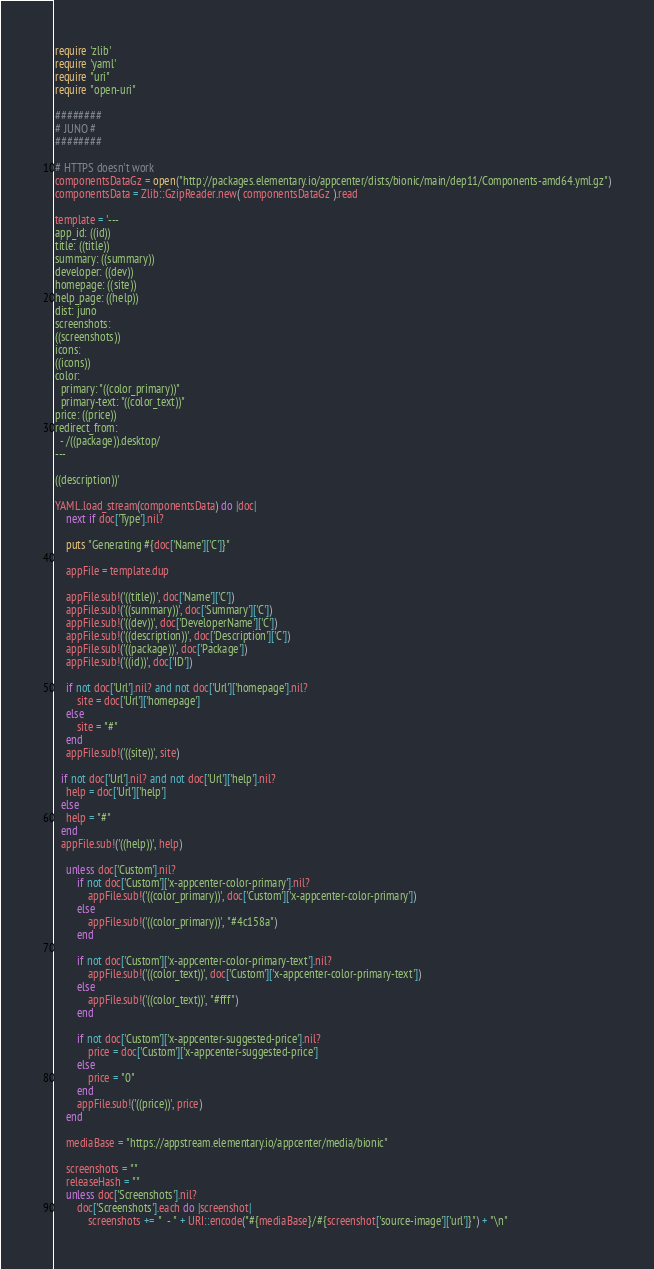<code> <loc_0><loc_0><loc_500><loc_500><_Ruby_>require 'zlib'
require 'yaml'
require "uri"
require "open-uri"

########
# JUNO #
########

# HTTPS doesn't work
componentsDataGz = open("http://packages.elementary.io/appcenter/dists/bionic/main/dep11/Components-amd64.yml.gz")
componentsData = Zlib::GzipReader.new( componentsDataGz ).read

template = '---
app_id: ((id))
title: ((title))
summary: ((summary))
developer: ((dev))
homepage: ((site))
help_page: ((help))
dist: juno
screenshots:
((screenshots))
icons:
((icons))
color:
  primary: "((color_primary))"
  primary-text: "((color_text))"
price: ((price))
redirect_from:
  - /((package)).desktop/
---

((description))'

YAML.load_stream(componentsData) do |doc|
	next if doc['Type'].nil?

	puts "Generating #{doc['Name']['C']}"

	appFile = template.dup

	appFile.sub!('((title))', doc['Name']['C'])
	appFile.sub!('((summary))', doc['Summary']['C'])
	appFile.sub!('((dev))', doc['DeveloperName']['C'])
	appFile.sub!('((description))', doc['Description']['C'])
	appFile.sub!('((package))', doc['Package'])
	appFile.sub!('((id))', doc['ID'])

	if not doc['Url'].nil? and not doc['Url']['homepage'].nil?
		site = doc['Url']['homepage']
	else
		site = "#"
	end
	appFile.sub!('((site))', site)

  if not doc['Url'].nil? and not doc['Url']['help'].nil?
    help = doc['Url']['help']
  else
    help = "#"
  end
  appFile.sub!('((help))', help)

	unless doc['Custom'].nil?
		if not doc['Custom']['x-appcenter-color-primary'].nil?
			appFile.sub!('((color_primary))', doc['Custom']['x-appcenter-color-primary'])
		else
			appFile.sub!('((color_primary))', "#4c158a")
		end

		if not doc['Custom']['x-appcenter-color-primary-text'].nil?
			appFile.sub!('((color_text))', doc['Custom']['x-appcenter-color-primary-text'])
		else
			appFile.sub!('((color_text))', "#fff")
		end

		if not doc['Custom']['x-appcenter-suggested-price'].nil?
			price = doc['Custom']['x-appcenter-suggested-price']
		else
			price = "0"
		end
		appFile.sub!('((price))', price)
	end

	mediaBase = "https://appstream.elementary.io/appcenter/media/bionic"

	screenshots = ""
	releaseHash = ""
	unless doc['Screenshots'].nil?
		doc['Screenshots'].each do |screenshot|
			screenshots += "  - " + URI::encode("#{mediaBase}/#{screenshot['source-image']['url']}") + "\n"</code> 